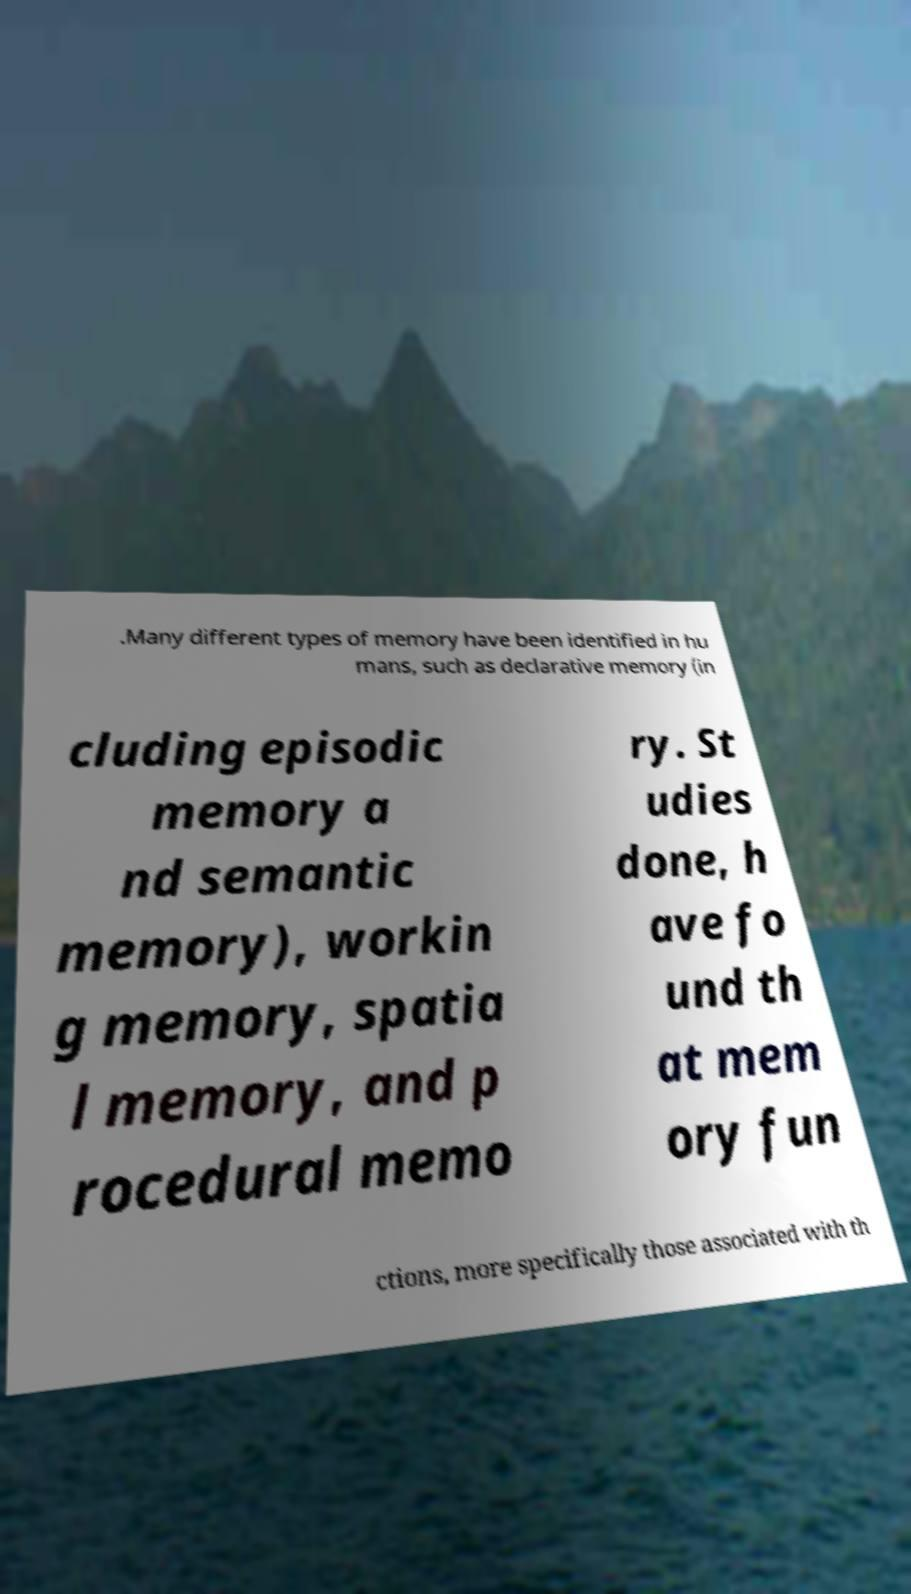Please read and relay the text visible in this image. What does it say? .Many different types of memory have been identified in hu mans, such as declarative memory (in cluding episodic memory a nd semantic memory), workin g memory, spatia l memory, and p rocedural memo ry. St udies done, h ave fo und th at mem ory fun ctions, more specifically those associated with th 